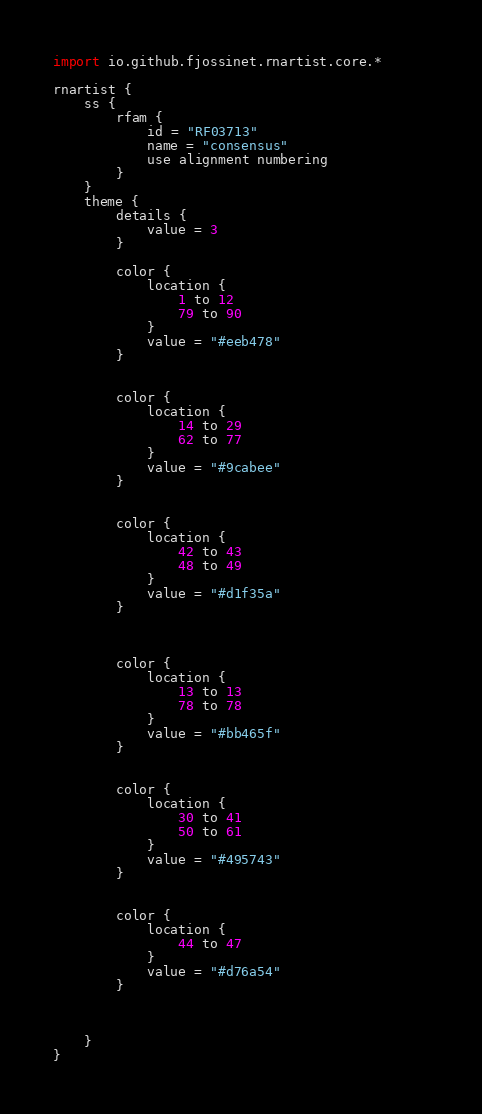Convert code to text. <code><loc_0><loc_0><loc_500><loc_500><_Kotlin_>import io.github.fjossinet.rnartist.core.*      

rnartist {
    ss {
        rfam {
            id = "RF03713"
            name = "consensus"
            use alignment numbering
        }
    }
    theme {
        details { 
            value = 3
        }

        color {
            location {
                1 to 12
                79 to 90
            }
            value = "#eeb478"
        }


        color {
            location {
                14 to 29
                62 to 77
            }
            value = "#9cabee"
        }


        color {
            location {
                42 to 43
                48 to 49
            }
            value = "#d1f35a"
        }



        color {
            location {
                13 to 13
                78 to 78
            }
            value = "#bb465f"
        }


        color {
            location {
                30 to 41
                50 to 61
            }
            value = "#495743"
        }


        color {
            location {
                44 to 47
            }
            value = "#d76a54"
        }



    }
}           </code> 